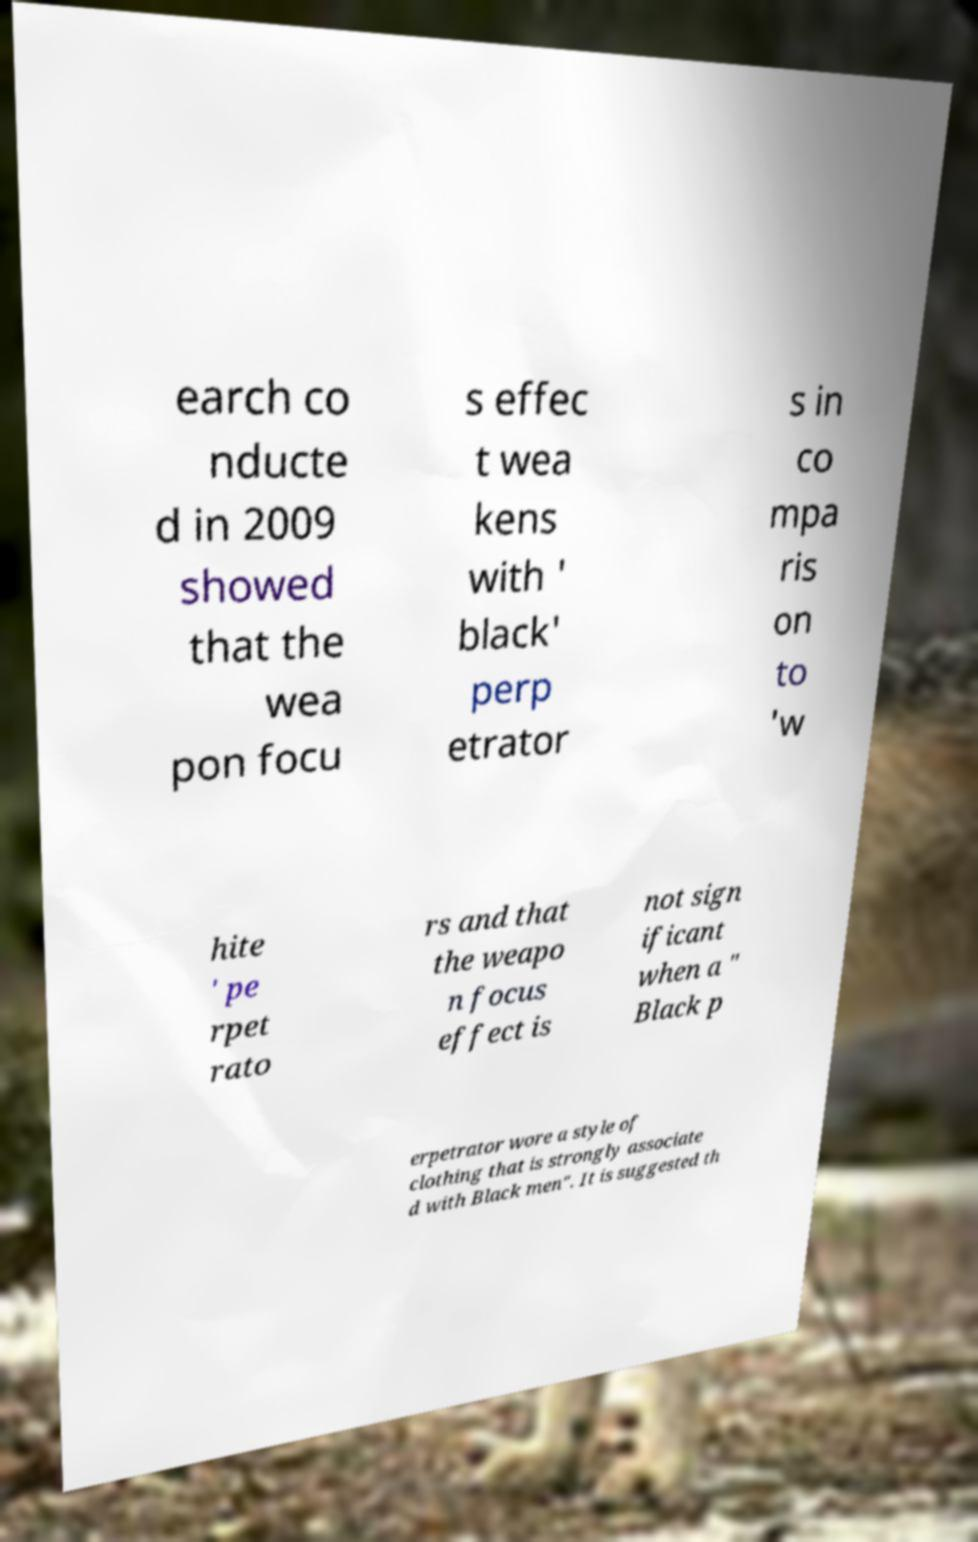Can you read and provide the text displayed in the image?This photo seems to have some interesting text. Can you extract and type it out for me? earch co nducte d in 2009 showed that the wea pon focu s effec t wea kens with ' black' perp etrator s in co mpa ris on to 'w hite ' pe rpet rato rs and that the weapo n focus effect is not sign ificant when a " Black p erpetrator wore a style of clothing that is strongly associate d with Black men". It is suggested th 